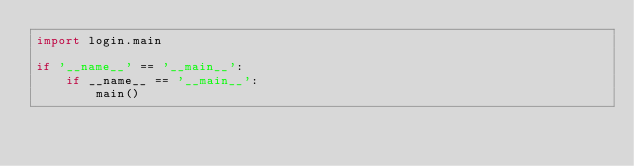<code> <loc_0><loc_0><loc_500><loc_500><_Python_>import login.main

if '__name__' == '__main__':
    if __name__ == '__main__':
        main()</code> 